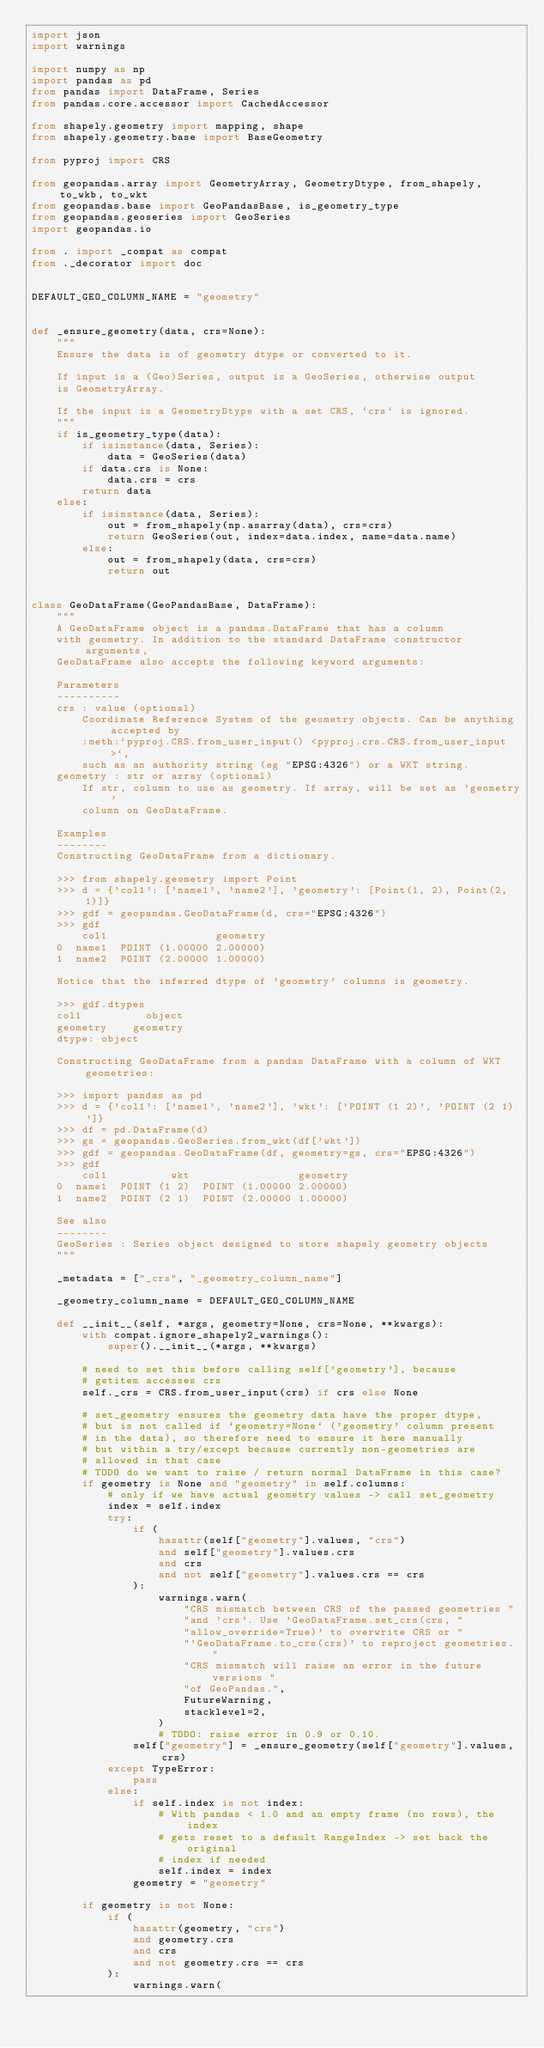<code> <loc_0><loc_0><loc_500><loc_500><_Python_>import json
import warnings

import numpy as np
import pandas as pd
from pandas import DataFrame, Series
from pandas.core.accessor import CachedAccessor

from shapely.geometry import mapping, shape
from shapely.geometry.base import BaseGeometry

from pyproj import CRS

from geopandas.array import GeometryArray, GeometryDtype, from_shapely, to_wkb, to_wkt
from geopandas.base import GeoPandasBase, is_geometry_type
from geopandas.geoseries import GeoSeries
import geopandas.io

from . import _compat as compat
from ._decorator import doc


DEFAULT_GEO_COLUMN_NAME = "geometry"


def _ensure_geometry(data, crs=None):
    """
    Ensure the data is of geometry dtype or converted to it.

    If input is a (Geo)Series, output is a GeoSeries, otherwise output
    is GeometryArray.

    If the input is a GeometryDtype with a set CRS, `crs` is ignored.
    """
    if is_geometry_type(data):
        if isinstance(data, Series):
            data = GeoSeries(data)
        if data.crs is None:
            data.crs = crs
        return data
    else:
        if isinstance(data, Series):
            out = from_shapely(np.asarray(data), crs=crs)
            return GeoSeries(out, index=data.index, name=data.name)
        else:
            out = from_shapely(data, crs=crs)
            return out


class GeoDataFrame(GeoPandasBase, DataFrame):
    """
    A GeoDataFrame object is a pandas.DataFrame that has a column
    with geometry. In addition to the standard DataFrame constructor arguments,
    GeoDataFrame also accepts the following keyword arguments:

    Parameters
    ----------
    crs : value (optional)
        Coordinate Reference System of the geometry objects. Can be anything accepted by
        :meth:`pyproj.CRS.from_user_input() <pyproj.crs.CRS.from_user_input>`,
        such as an authority string (eg "EPSG:4326") or a WKT string.
    geometry : str or array (optional)
        If str, column to use as geometry. If array, will be set as 'geometry'
        column on GeoDataFrame.

    Examples
    --------
    Constructing GeoDataFrame from a dictionary.

    >>> from shapely.geometry import Point
    >>> d = {'col1': ['name1', 'name2'], 'geometry': [Point(1, 2), Point(2, 1)]}
    >>> gdf = geopandas.GeoDataFrame(d, crs="EPSG:4326")
    >>> gdf
        col1                 geometry
    0  name1  POINT (1.00000 2.00000)
    1  name2  POINT (2.00000 1.00000)

    Notice that the inferred dtype of 'geometry' columns is geometry.

    >>> gdf.dtypes
    col1          object
    geometry    geometry
    dtype: object

    Constructing GeoDataFrame from a pandas DataFrame with a column of WKT geometries:

    >>> import pandas as pd
    >>> d = {'col1': ['name1', 'name2'], 'wkt': ['POINT (1 2)', 'POINT (2 1)']}
    >>> df = pd.DataFrame(d)
    >>> gs = geopandas.GeoSeries.from_wkt(df['wkt'])
    >>> gdf = geopandas.GeoDataFrame(df, geometry=gs, crs="EPSG:4326")
    >>> gdf
        col1          wkt                 geometry
    0  name1  POINT (1 2)  POINT (1.00000 2.00000)
    1  name2  POINT (2 1)  POINT (2.00000 1.00000)

    See also
    --------
    GeoSeries : Series object designed to store shapely geometry objects
    """

    _metadata = ["_crs", "_geometry_column_name"]

    _geometry_column_name = DEFAULT_GEO_COLUMN_NAME

    def __init__(self, *args, geometry=None, crs=None, **kwargs):
        with compat.ignore_shapely2_warnings():
            super().__init__(*args, **kwargs)

        # need to set this before calling self['geometry'], because
        # getitem accesses crs
        self._crs = CRS.from_user_input(crs) if crs else None

        # set_geometry ensures the geometry data have the proper dtype,
        # but is not called if `geometry=None` ('geometry' column present
        # in the data), so therefore need to ensure it here manually
        # but within a try/except because currently non-geometries are
        # allowed in that case
        # TODO do we want to raise / return normal DataFrame in this case?
        if geometry is None and "geometry" in self.columns:
            # only if we have actual geometry values -> call set_geometry
            index = self.index
            try:
                if (
                    hasattr(self["geometry"].values, "crs")
                    and self["geometry"].values.crs
                    and crs
                    and not self["geometry"].values.crs == crs
                ):
                    warnings.warn(
                        "CRS mismatch between CRS of the passed geometries "
                        "and 'crs'. Use 'GeoDataFrame.set_crs(crs, "
                        "allow_override=True)' to overwrite CRS or "
                        "'GeoDataFrame.to_crs(crs)' to reproject geometries. "
                        "CRS mismatch will raise an error in the future versions "
                        "of GeoPandas.",
                        FutureWarning,
                        stacklevel=2,
                    )
                    # TODO: raise error in 0.9 or 0.10.
                self["geometry"] = _ensure_geometry(self["geometry"].values, crs)
            except TypeError:
                pass
            else:
                if self.index is not index:
                    # With pandas < 1.0 and an empty frame (no rows), the index
                    # gets reset to a default RangeIndex -> set back the original
                    # index if needed
                    self.index = index
                geometry = "geometry"

        if geometry is not None:
            if (
                hasattr(geometry, "crs")
                and geometry.crs
                and crs
                and not geometry.crs == crs
            ):
                warnings.warn(</code> 